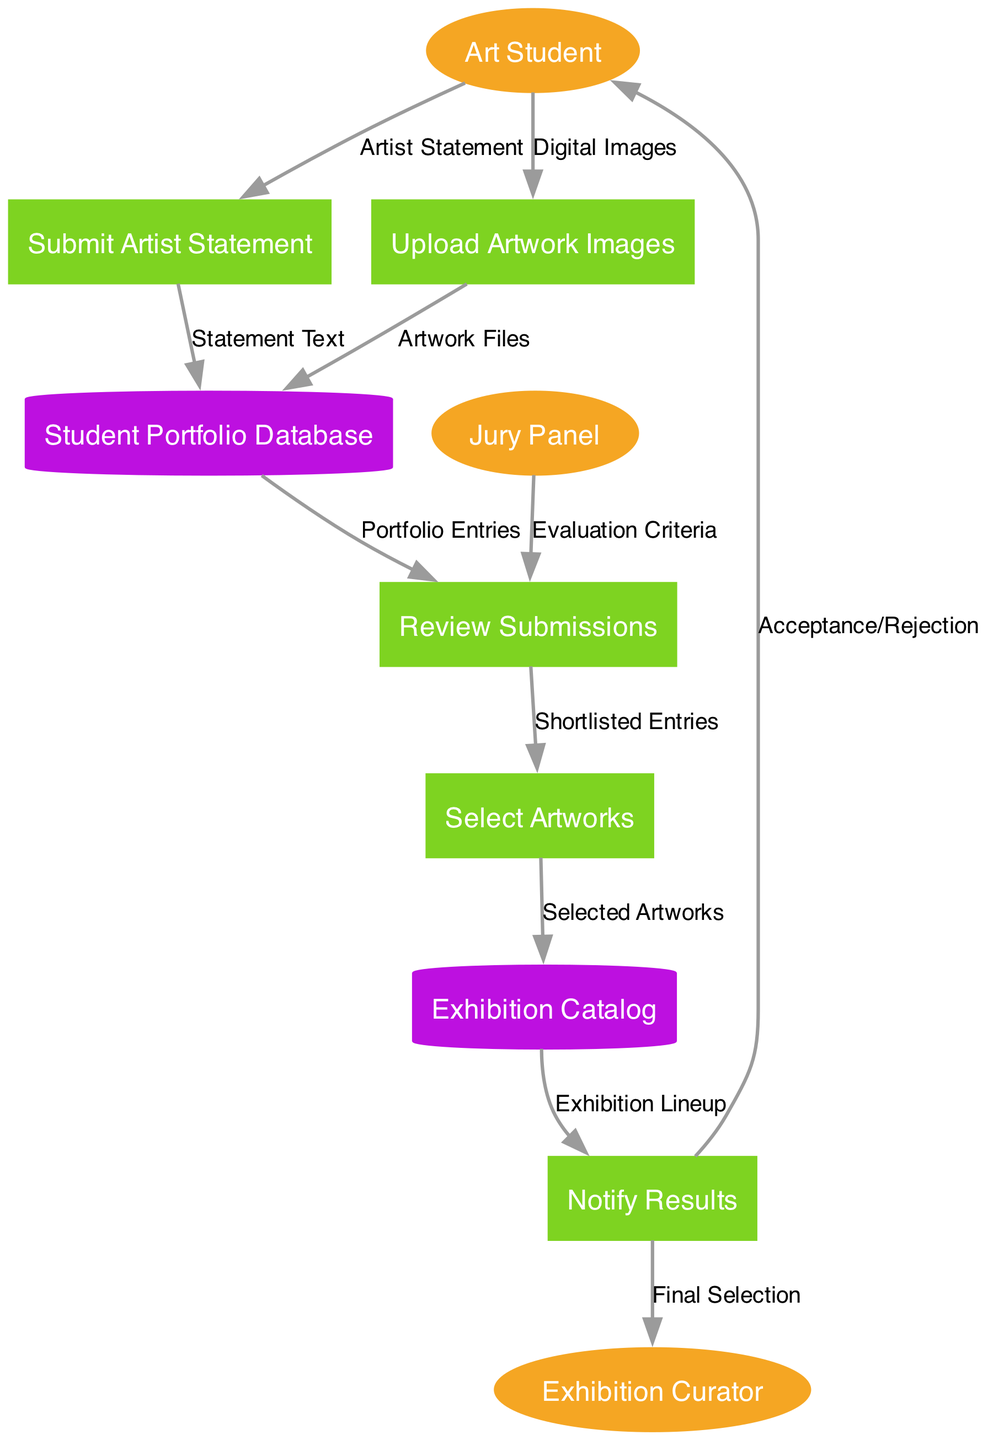What are the external entities? The diagram lists three external entities: Art Student, Jury Panel, and Exhibition Curator. These entities represent the key participants involved in the online art portfolio submission process.
Answer: Art Student, Jury Panel, Exhibition Curator How many processes are there in the diagram? The diagram contains five distinct processes that outline the steps in the submission and review process: Upload Artwork Images, Submit Artist Statement, Review Submissions, Select Artworks, and Notify Results.
Answer: Five What is the data flow from the Art Student to the Student Portfolio Database? The Art Student uploads digital images to the Upload Artwork Images process, which creates artwork files that flow into the Student Portfolio Database. The Artist Statement submitted by the Art Student also goes to the same database as statement text. Both contribute to the entries in the portfolio.
Answer: Artwork Files, Statement Text Which process receives Evaluation Criteria? The Review Submissions process is where the Jury Panel provides the Evaluation Criteria, which guides how the submissions are evaluated and shortlisted for selection.
Answer: Review Submissions What happens to the short-listed entries after the Review Submissions process? Once the Review Submissions process is complete, it forwards the shortlisted entries to the Select Artworks process, where the final selection of artworks for the exhibition is made.
Answer: Select Artworks What does Notify Results send to the Art Student? The Notify Results process communicates the acceptance or rejection of their submissions to the Art Student, thus providing the outcome of their portfolio submission.
Answer: Acceptance/Rejection What is stored in the Exhibition Catalog? The Exhibition Catalog contains the selected artworks that have been finalized for the exhibition, essentially comprising the lineup that will be displayed.
Answer: Selected Artworks How many data stores are present in the diagram? There are two data stores represented in the diagram: the Student Portfolio Database and the Exhibition Catalog, both serving as repositories for relevant information during the process.
Answer: Two What data flows from the Exhibition Catalog to the Notify Results? The data flow from the Exhibition Catalog to Notify Results consists of the exhibition lineup, which includes details about which artworks have been selected for the exhibition.
Answer: Exhibition Lineup Which process is the final step in the diagram? The Notify Results process is the final step in the diagram, as it concludes the submission process by informing all parties about the results of the selection.
Answer: Notify Results 